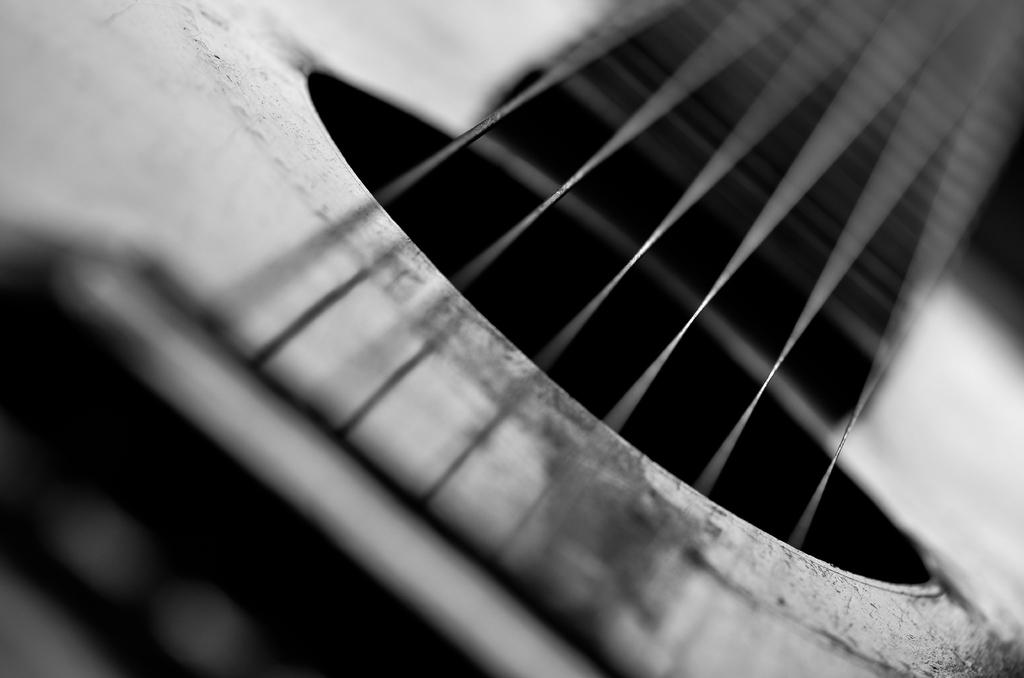What is the main object in the picture? There is a guitar in the picture. Can you describe the perspective of the picture? The picture provides a closer view of the guitar. What are the guitar's functional components? The guitar has strings. What color is the orange that is being peeled in the picture? There is no orange present in the picture; it features a guitar. 